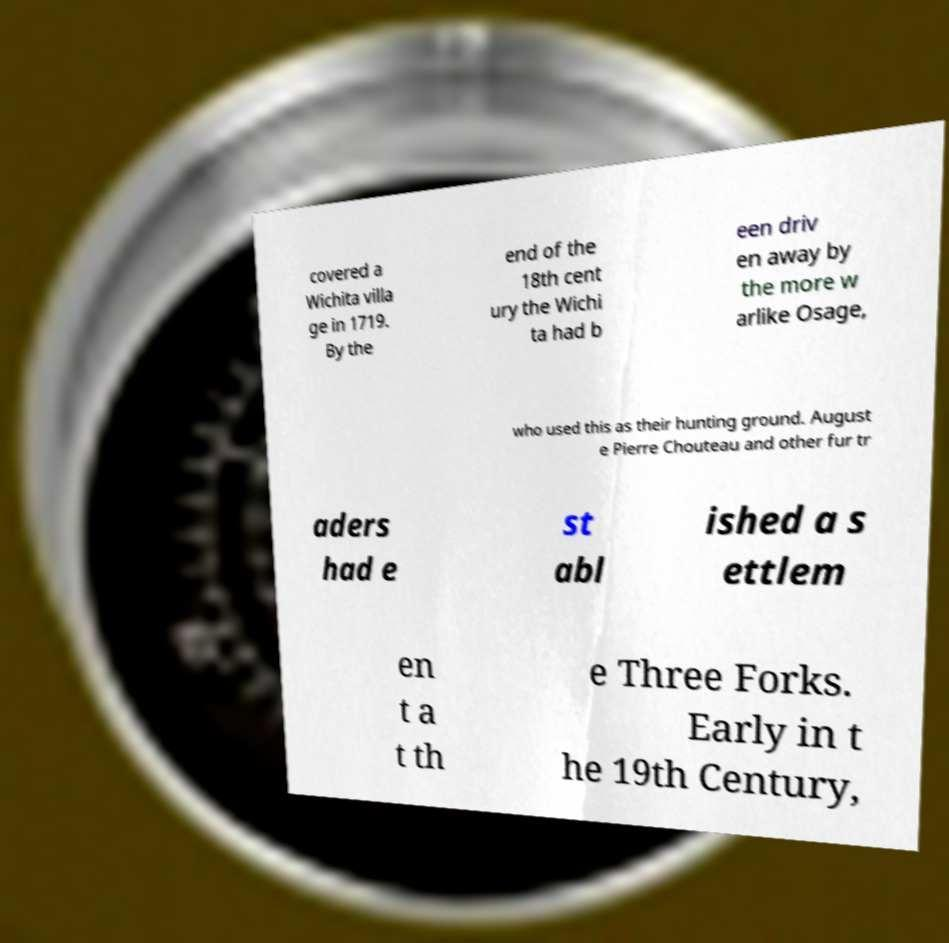Could you extract and type out the text from this image? covered a Wichita villa ge in 1719. By the end of the 18th cent ury the Wichi ta had b een driv en away by the more w arlike Osage, who used this as their hunting ground. August e Pierre Chouteau and other fur tr aders had e st abl ished a s ettlem en t a t th e Three Forks. Early in t he 19th Century, 